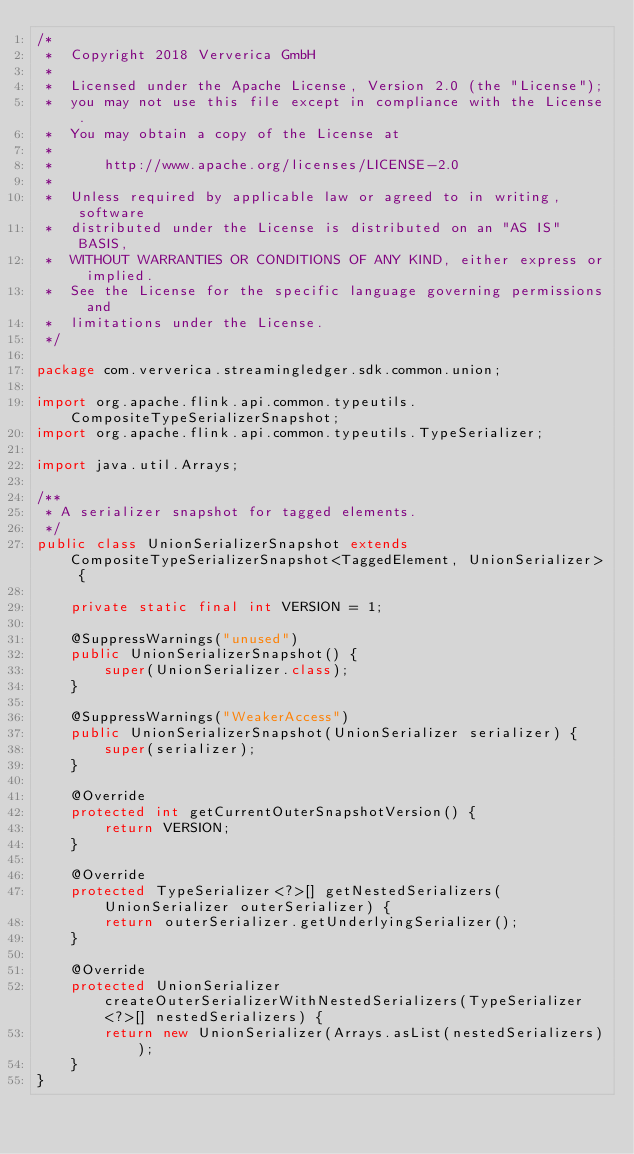Convert code to text. <code><loc_0><loc_0><loc_500><loc_500><_Java_>/*
 *  Copyright 2018 Ververica GmbH
 *
 *  Licensed under the Apache License, Version 2.0 (the "License");
 *  you may not use this file except in compliance with the License.
 *  You may obtain a copy of the License at
 *
 *      http://www.apache.org/licenses/LICENSE-2.0
 *
 *  Unless required by applicable law or agreed to in writing, software
 *  distributed under the License is distributed on an "AS IS" BASIS,
 *  WITHOUT WARRANTIES OR CONDITIONS OF ANY KIND, either express or implied.
 *  See the License for the specific language governing permissions and
 *  limitations under the License.
 */

package com.ververica.streamingledger.sdk.common.union;

import org.apache.flink.api.common.typeutils.CompositeTypeSerializerSnapshot;
import org.apache.flink.api.common.typeutils.TypeSerializer;

import java.util.Arrays;

/**
 * A serializer snapshot for tagged elements.
 */
public class UnionSerializerSnapshot extends CompositeTypeSerializerSnapshot<TaggedElement, UnionSerializer> {

    private static final int VERSION = 1;

    @SuppressWarnings("unused")
    public UnionSerializerSnapshot() {
        super(UnionSerializer.class);
    }

    @SuppressWarnings("WeakerAccess")
    public UnionSerializerSnapshot(UnionSerializer serializer) {
        super(serializer);
    }

    @Override
    protected int getCurrentOuterSnapshotVersion() {
        return VERSION;
    }

    @Override
    protected TypeSerializer<?>[] getNestedSerializers(UnionSerializer outerSerializer) {
        return outerSerializer.getUnderlyingSerializer();
    }

    @Override
    protected UnionSerializer createOuterSerializerWithNestedSerializers(TypeSerializer<?>[] nestedSerializers) {
        return new UnionSerializer(Arrays.asList(nestedSerializers));
    }
}
</code> 